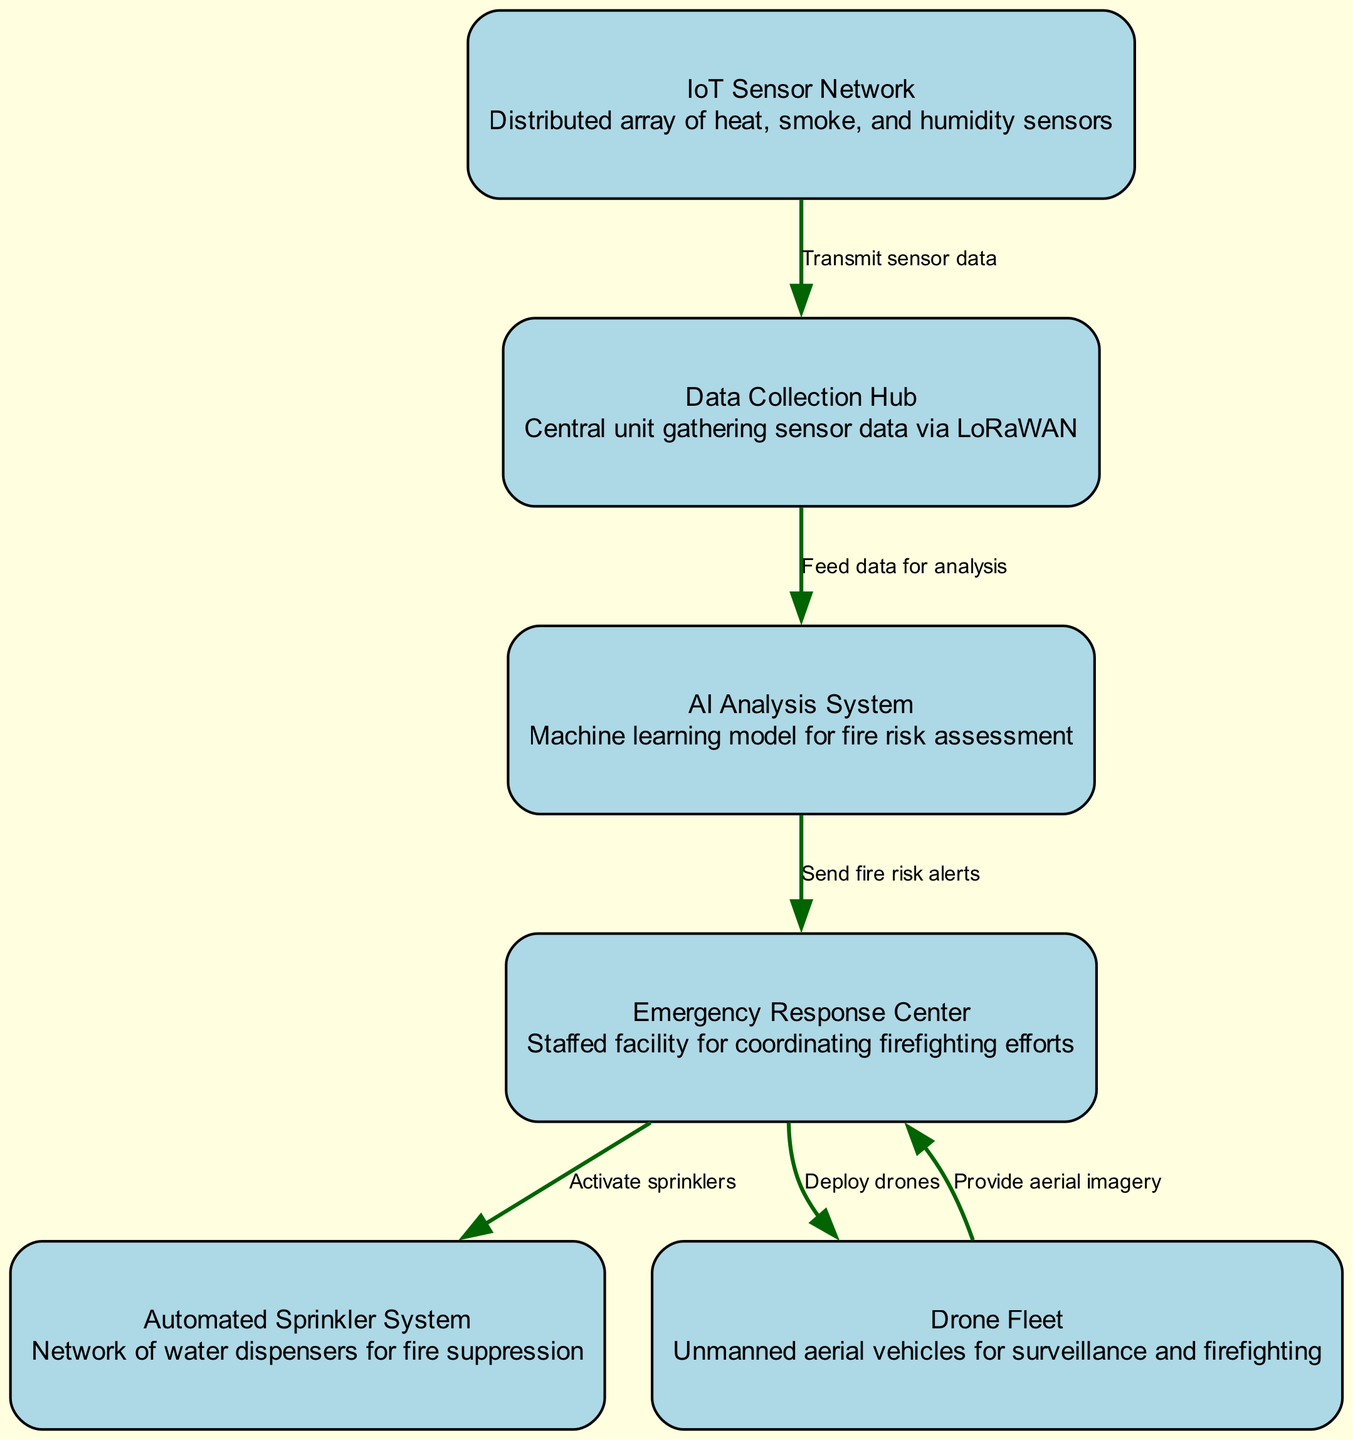What is the first component in the system? The first component in the diagram is the "IoT Sensor Network," which acts as the initial source of data for detecting potential fire hazards.
Answer: IoT Sensor Network How many nodes are there in total? The diagram includes a total of six nodes: IoT Sensor Network, Data Collection Hub, AI Analysis System, Emergency Response Center, Automated Sprinkler System, and Drone Fleet.
Answer: 6 Which node receives data directly from the IoT Sensor Network? The "Data Collection Hub" is the node that directly receives data transmitted from the IoT Sensor Network for further processing.
Answer: Data Collection Hub What action does the Emergency Response Center take upon receiving fire risk alerts? Upon receiving fire risk alerts, the Emergency Response Center activates the Automated Sprinkler System as part of the emergency response measures to combat potential fires.
Answer: Activate sprinklers Which nodes does the Drone Fleet provide information to? The Drone Fleet provides aerial imagery back to the Emergency Response Center, facilitating better-informed decision-making during firefighting efforts.
Answer: Emergency Response Center What is the function of the AI Analysis System in the workflow? The AI Analysis System analyzes the data received from the Data Collection Hub and assesses fire risk, which is crucial for timely alerts to the Emergency Response Center.
Answer: Fire risk assessment What is the relationship between the AI Analysis System and the Emergency Response Center? The AI Analysis System sends fire risk alerts to the Emergency Response Center based on its analysis of the data from the Data Collection Hub, establishing a communication link for emergency actions.
Answer: Send fire risk alerts How does the Automated Sprinkler System get triggered? The Automated Sprinkler System is triggered by actions taken from the Emergency Response Center, which activates it to help suppress any detected fires.
Answer: Activated by Emergency Response Center 